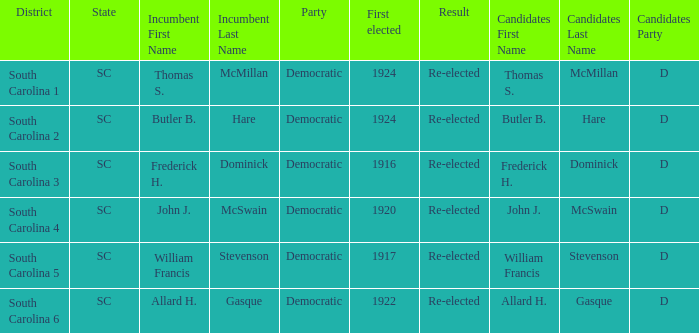What is the overall count of outcomes where the district is south carolina 5? 1.0. 